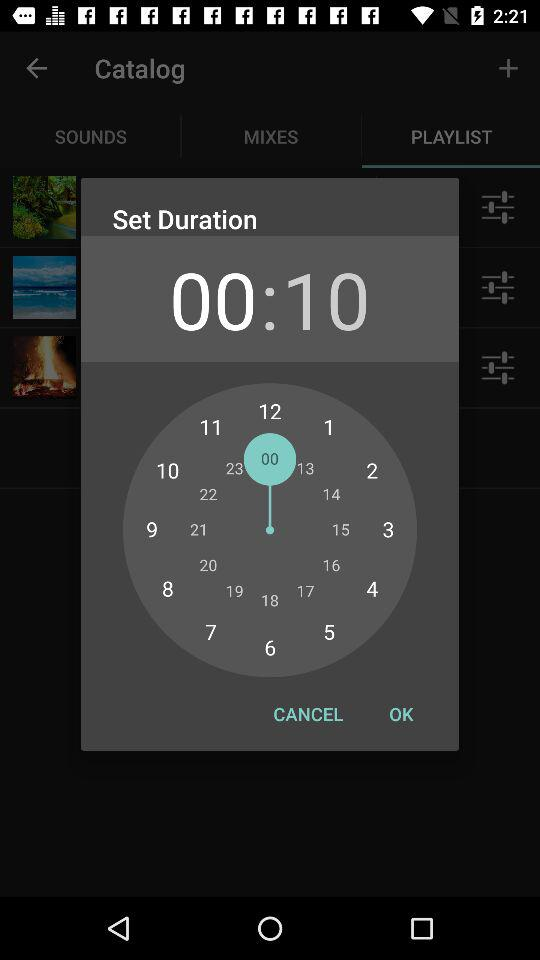How many seconds are there in the length of the recording?
Answer the question using a single word or phrase. 10 